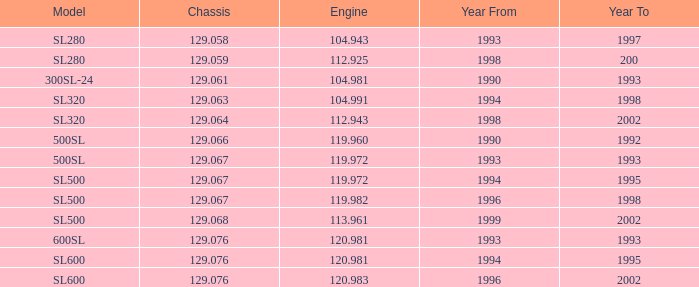How many engines have a Model of sl600, and a Year From of 1994, and a Year To smaller than 1995? 0.0. 